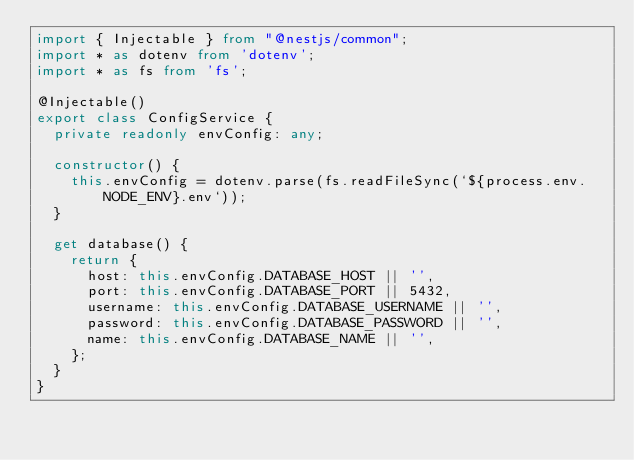Convert code to text. <code><loc_0><loc_0><loc_500><loc_500><_TypeScript_>import { Injectable } from "@nestjs/common";
import * as dotenv from 'dotenv';
import * as fs from 'fs';

@Injectable()
export class ConfigService {
  private readonly envConfig: any;

  constructor() {
    this.envConfig = dotenv.parse(fs.readFileSync(`${process.env.NODE_ENV}.env`));
  }

  get database() {
    return {
      host: this.envConfig.DATABASE_HOST || '',
      port: this.envConfig.DATABASE_PORT || 5432,
      username: this.envConfig.DATABASE_USERNAME || '',
      password: this.envConfig.DATABASE_PASSWORD || '',
      name: this.envConfig.DATABASE_NAME || '',
    };
  }
}</code> 